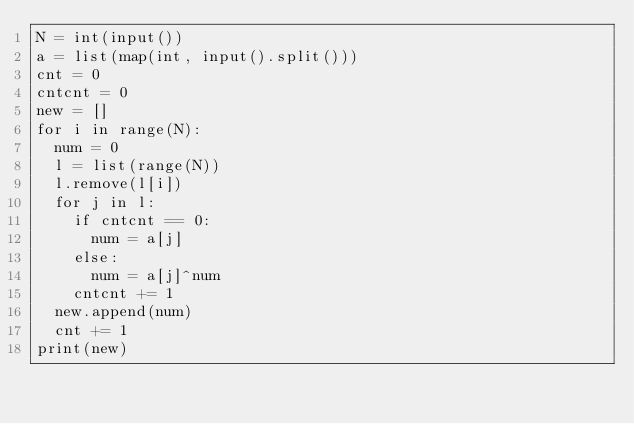<code> <loc_0><loc_0><loc_500><loc_500><_Python_>N = int(input())
a = list(map(int, input().split()))
cnt = 0
cntcnt = 0
new = []
for i in range(N):
  num = 0
  l = list(range(N))
  l.remove(l[i])
  for j in l:
    if cntcnt == 0:
      num = a[j]
    else:
      num = a[j]^num
    cntcnt += 1
  new.append(num)
  cnt += 1
print(new)</code> 